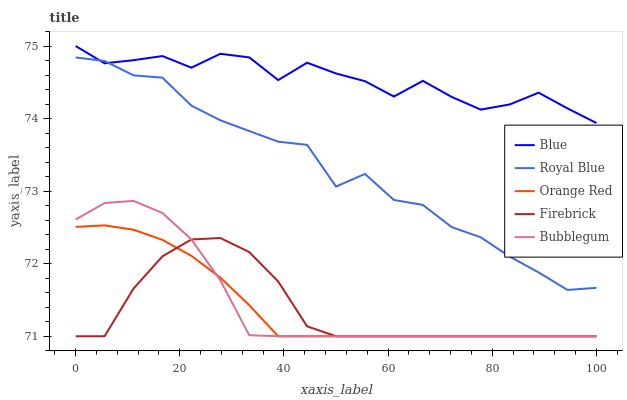Does Royal Blue have the minimum area under the curve?
Answer yes or no. No. Does Royal Blue have the maximum area under the curve?
Answer yes or no. No. Is Royal Blue the smoothest?
Answer yes or no. No. Is Royal Blue the roughest?
Answer yes or no. No. Does Royal Blue have the lowest value?
Answer yes or no. No. Does Royal Blue have the highest value?
Answer yes or no. No. Is Bubblegum less than Royal Blue?
Answer yes or no. Yes. Is Royal Blue greater than Orange Red?
Answer yes or no. Yes. Does Bubblegum intersect Royal Blue?
Answer yes or no. No. 